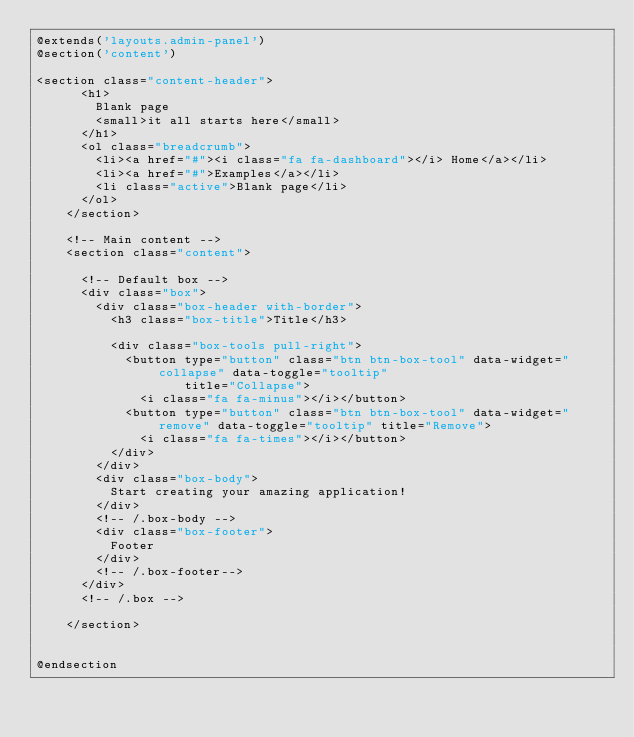Convert code to text. <code><loc_0><loc_0><loc_500><loc_500><_PHP_>@extends('layouts.admin-panel')
@section('content')

<section class="content-header">
      <h1>
        Blank page
        <small>it all starts here</small>
      </h1>
      <ol class="breadcrumb">
        <li><a href="#"><i class="fa fa-dashboard"></i> Home</a></li>
        <li><a href="#">Examples</a></li>
        <li class="active">Blank page</li>
      </ol>
    </section>

    <!-- Main content -->
    <section class="content">

      <!-- Default box -->
      <div class="box">
        <div class="box-header with-border">
          <h3 class="box-title">Title</h3>

          <div class="box-tools pull-right">
            <button type="button" class="btn btn-box-tool" data-widget="collapse" data-toggle="tooltip"
                    title="Collapse">
              <i class="fa fa-minus"></i></button>
            <button type="button" class="btn btn-box-tool" data-widget="remove" data-toggle="tooltip" title="Remove">
              <i class="fa fa-times"></i></button>
          </div>
        </div>
        <div class="box-body">
          Start creating your amazing application!
        </div>
        <!-- /.box-body -->
        <div class="box-footer">
          Footer
        </div>
        <!-- /.box-footer-->
      </div>
      <!-- /.box -->

    </section>


@endsection</code> 